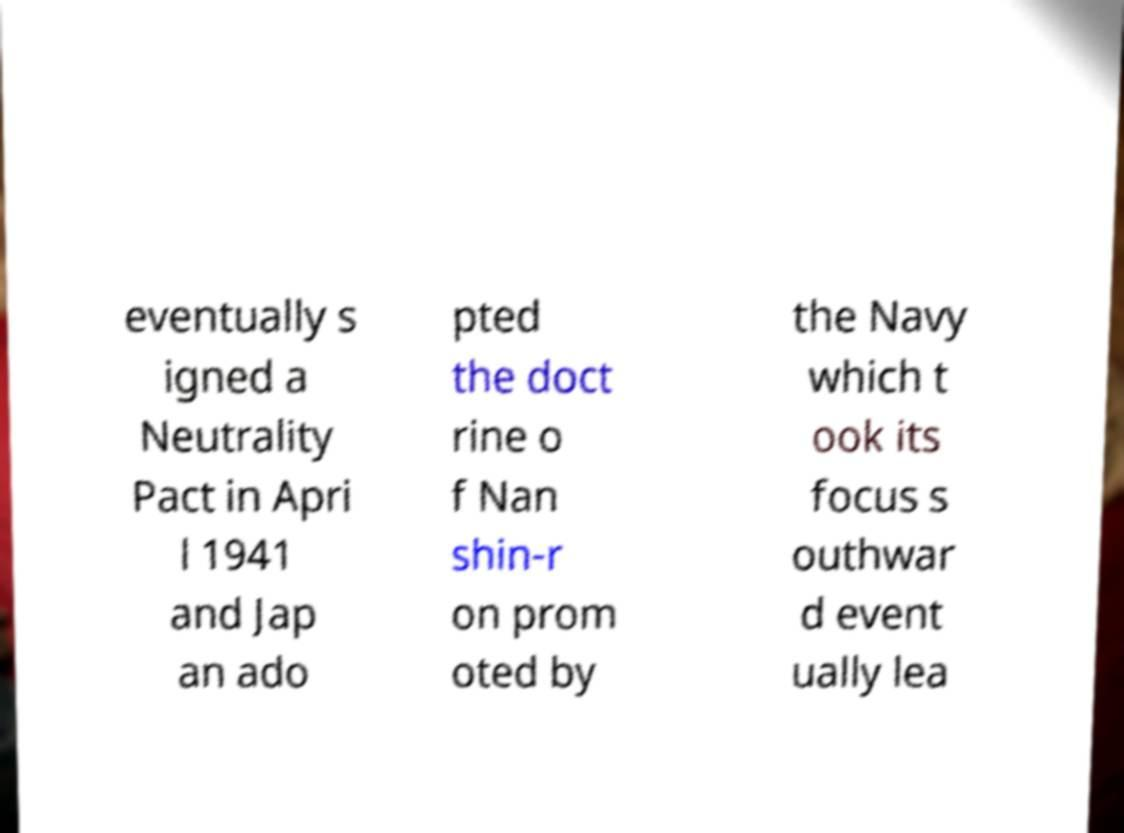Could you assist in decoding the text presented in this image and type it out clearly? eventually s igned a Neutrality Pact in Apri l 1941 and Jap an ado pted the doct rine o f Nan shin-r on prom oted by the Navy which t ook its focus s outhwar d event ually lea 